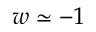Convert formula to latex. <formula><loc_0><loc_0><loc_500><loc_500>w \simeq - 1</formula> 